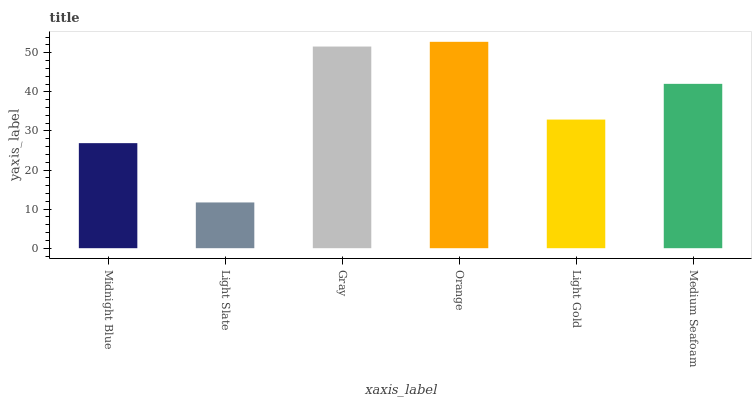Is Light Slate the minimum?
Answer yes or no. Yes. Is Orange the maximum?
Answer yes or no. Yes. Is Gray the minimum?
Answer yes or no. No. Is Gray the maximum?
Answer yes or no. No. Is Gray greater than Light Slate?
Answer yes or no. Yes. Is Light Slate less than Gray?
Answer yes or no. Yes. Is Light Slate greater than Gray?
Answer yes or no. No. Is Gray less than Light Slate?
Answer yes or no. No. Is Medium Seafoam the high median?
Answer yes or no. Yes. Is Light Gold the low median?
Answer yes or no. Yes. Is Gray the high median?
Answer yes or no. No. Is Midnight Blue the low median?
Answer yes or no. No. 